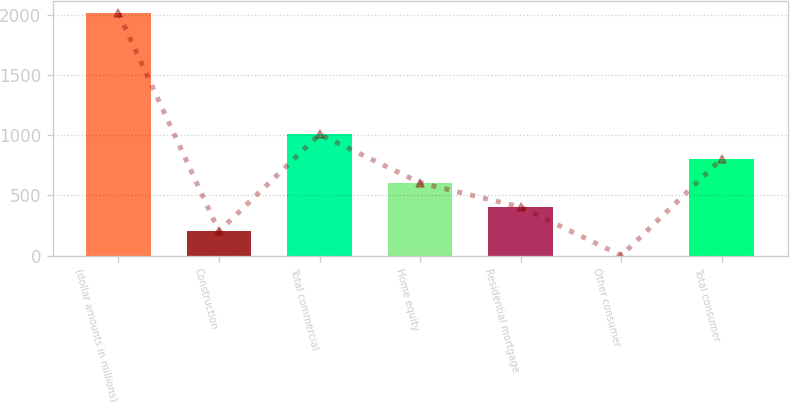Convert chart to OTSL. <chart><loc_0><loc_0><loc_500><loc_500><bar_chart><fcel>(dollar amounts in millions)<fcel>Construction<fcel>Total commercial<fcel>Home equity<fcel>Residential mortgage<fcel>Other consumer<fcel>Total consumer<nl><fcel>2015<fcel>202.4<fcel>1008<fcel>605.2<fcel>403.8<fcel>1<fcel>806.6<nl></chart> 